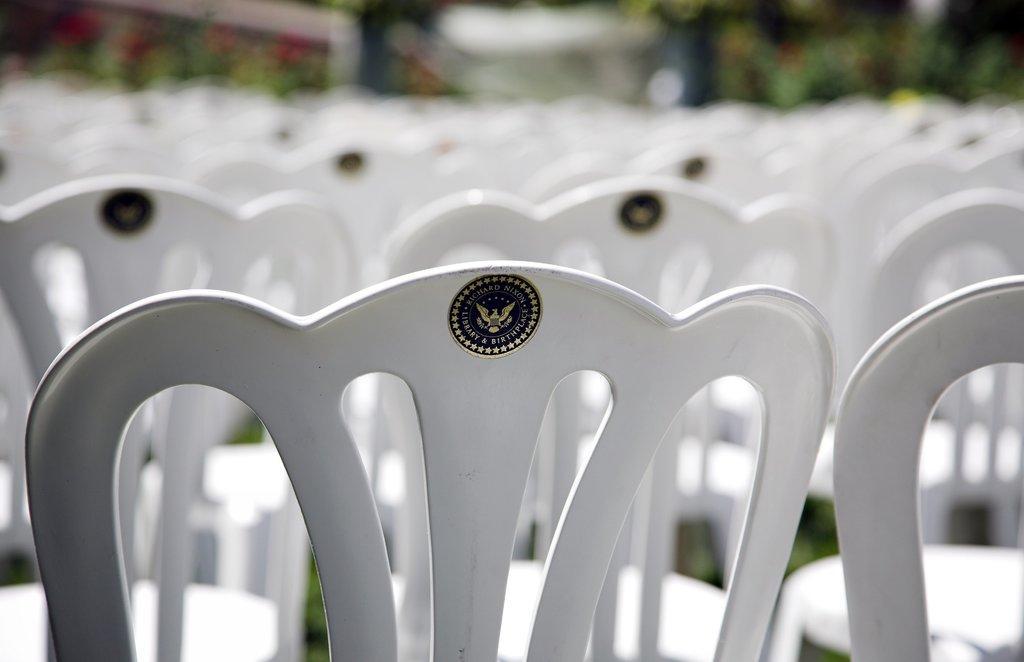Please provide a concise description of this image. As we can see in the image in the front there are group of chairs. In the background there are trees and the background is little blurred. 